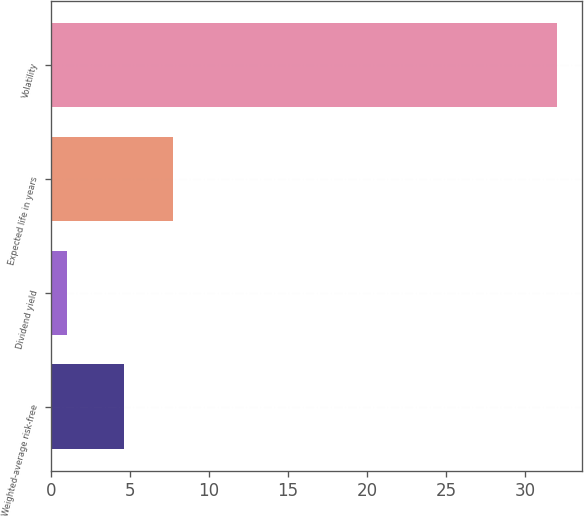Convert chart. <chart><loc_0><loc_0><loc_500><loc_500><bar_chart><fcel>Weighted-average risk-free<fcel>Dividend yield<fcel>Expected life in years<fcel>Volatility<nl><fcel>4.6<fcel>1<fcel>7.7<fcel>32<nl></chart> 